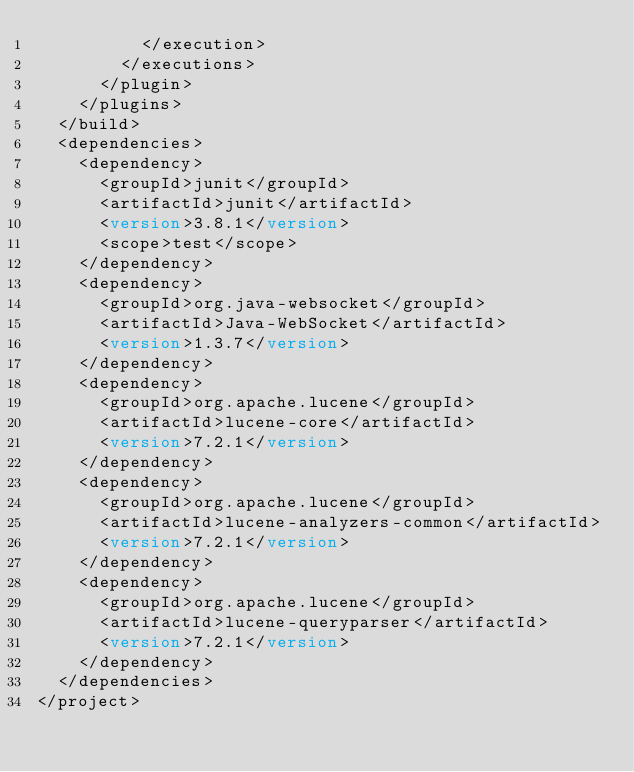<code> <loc_0><loc_0><loc_500><loc_500><_XML_>					</execution>
				</executions>
			</plugin>
		</plugins>
	</build>
	<dependencies>
		<dependency>
			<groupId>junit</groupId>
			<artifactId>junit</artifactId>
			<version>3.8.1</version>
			<scope>test</scope>
		</dependency>
		<dependency>
			<groupId>org.java-websocket</groupId>
			<artifactId>Java-WebSocket</artifactId>
			<version>1.3.7</version>
		</dependency>
		<dependency>
			<groupId>org.apache.lucene</groupId>
			<artifactId>lucene-core</artifactId>
			<version>7.2.1</version>
		</dependency>
		<dependency>
			<groupId>org.apache.lucene</groupId>
			<artifactId>lucene-analyzers-common</artifactId>
			<version>7.2.1</version>
		</dependency>
		<dependency>
			<groupId>org.apache.lucene</groupId>
			<artifactId>lucene-queryparser</artifactId>
			<version>7.2.1</version>
		</dependency>
	</dependencies>
</project>

</code> 